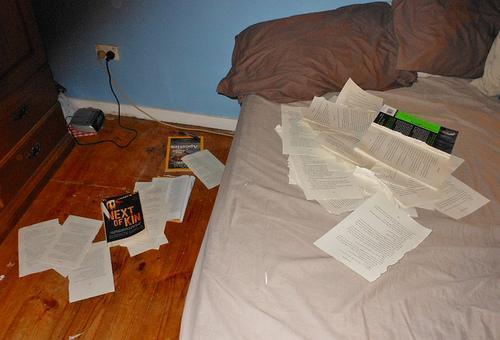How many books are on the floor?
Give a very brief answer. 2. 